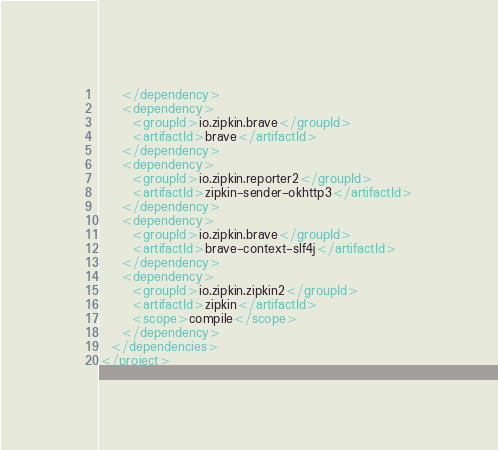<code> <loc_0><loc_0><loc_500><loc_500><_XML_>    </dependency>
    <dependency>
      <groupId>io.zipkin.brave</groupId>
      <artifactId>brave</artifactId>
    </dependency>
    <dependency>
      <groupId>io.zipkin.reporter2</groupId>
      <artifactId>zipkin-sender-okhttp3</artifactId>
    </dependency>
    <dependency>
      <groupId>io.zipkin.brave</groupId>
      <artifactId>brave-context-slf4j</artifactId>
    </dependency>
    <dependency>
      <groupId>io.zipkin.zipkin2</groupId>
      <artifactId>zipkin</artifactId>
      <scope>compile</scope>
    </dependency>
  </dependencies>
</project>
</code> 